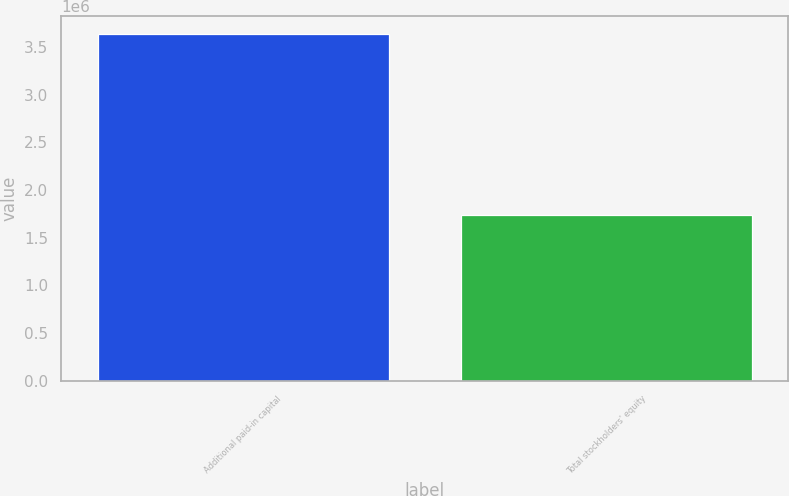<chart> <loc_0><loc_0><loc_500><loc_500><bar_chart><fcel>Additional paid-in capital<fcel>Total stockholders' equity<nl><fcel>3.64202e+06<fcel>1.74032e+06<nl></chart> 